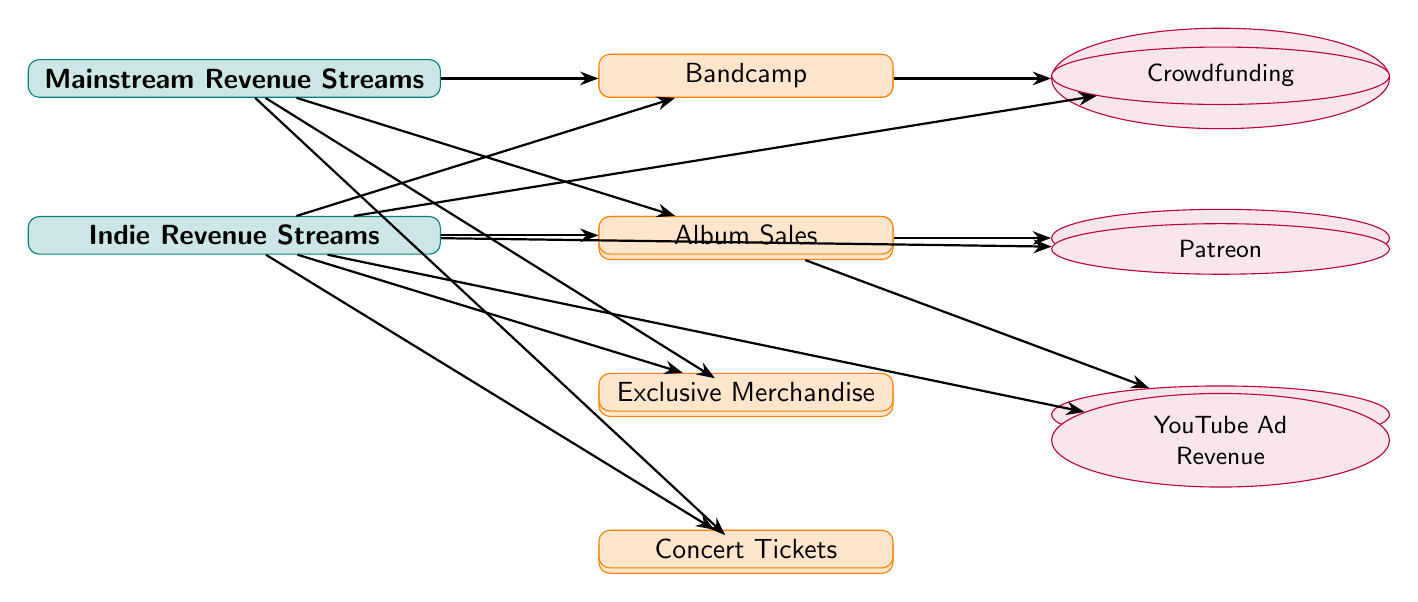What are the two main categories of revenue streams? The diagram shows two main categories: Mainstream Revenue Streams and Indie Revenue Streams. These categories are highlighted as the two primary nodes at the top of the diagram.
Answer: Mainstream Revenue Streams, Indie Revenue Streams How many sub-nodes are under Mainstream Revenue Streams? The diagram lists four sub-nodes under Mainstream Revenue Streams: Album Sales, Streaming Services, Merchandise, and Live Performances, which can be counted directly in the diagram.
Answer: 4 What revenue stream is associated with Album Sales in the mainstream category? The diagram connects Album Sales to a leaf node labeled Record Label Royalties, indicating that this is the associated revenue derived from album sales.
Answer: Record Label Royalties Which revenue stream appears only in the Indie category? By reviewing the Indie category's revenue streams, the diagram indicates that Bandcamp, located above Album Sales in the indie section, is not present in the mainstream section, marking it as unique to Indie.
Answer: Bandcamp How are Concert Tickets categorized in the Indie Revenue Streams? Looking at the Indie Revenue Streams, Concert Tickets is listed as a sub-node beneath Exclusive Merchandise, indicating its place in the overall financial structure and its specific categorization.
Answer: Live Performances What are the types of platforms mentioned for streaming in the mainstream streams category? The diagram specifies two streaming platforms that are connected beneath Streaming Services: Spotify and Apple Music, which directly relate to the income from streaming for mainstream artists.
Answer: Spotify, Apple Music Which revenue stream has the most direct connections in the Indie category? The diagram shows that the Indie category connects directly to three leaf nodes: Crowdfunding, Patreon, and YouTube Ad Revenue, indicating multiple revenue options linked to Native Paths.
Answer: Crowdfunding, Patreon, YouTube Ad Revenue Which revenue stream provides exclusive merchandise in the Indie scene? The diagram illustrates that Exclusive Merchandise is a unique sub-node under the Indie category and emphasizes that it's only present in the context of indie revenue streams, separating it from the mainstream offerings.
Answer: Exclusive Merchandise 